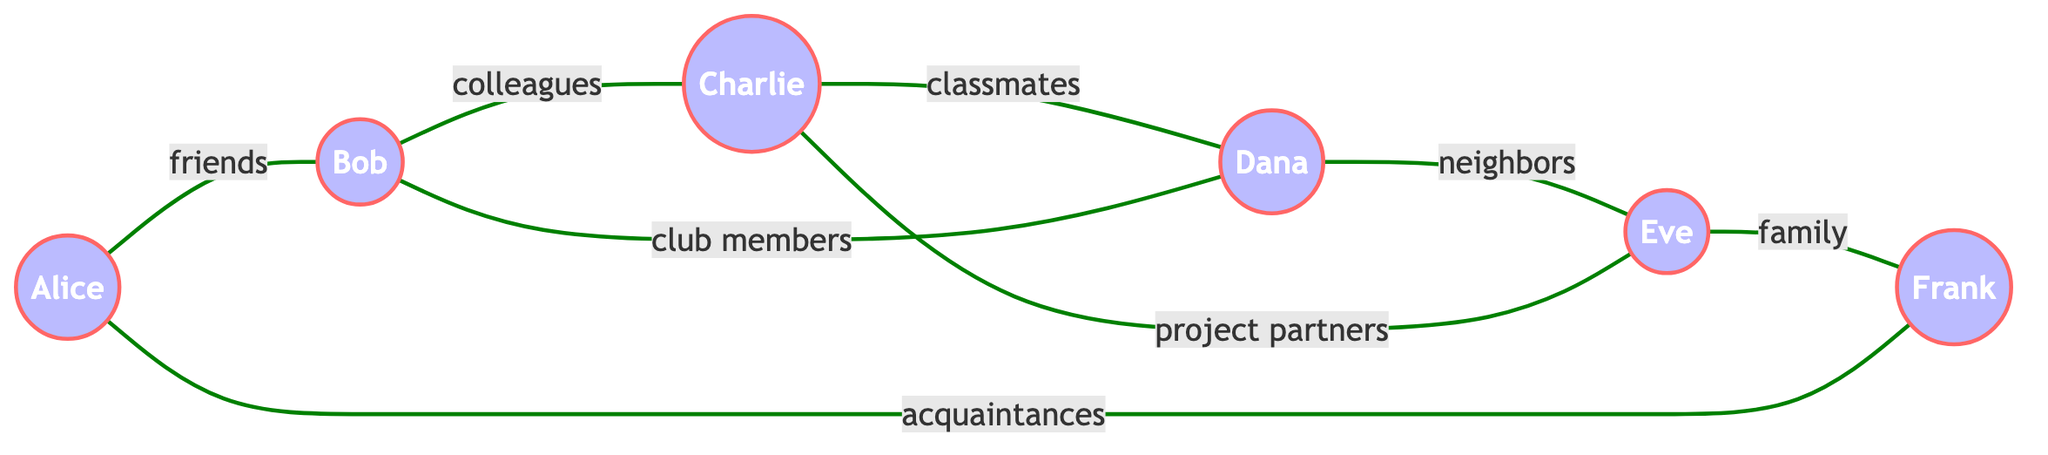What is the total number of nodes in the graph? The nodes in the graph are Alice, Bob, Charlie, Dana, Eve, and Frank. Counting these, there are six nodes in total.
Answer: 6 Which node is connected to both Bob and Dana? Observing the edges, Bob (Node 2) connects to Charlie (Node 3) and Dana (Node 4). Since Dana is directly connected to Bob's direct connection (Charlie), we recognize that there are shared connections through different nodes. The direct connection can be seen from Node 2 to Node 4.
Answer: Dana What relationship connects Alice and Frank? Checking the edge between Alice (Node 1) and Frank (Node 6), the relationship is defined as "acquaintances." Thus, we identify the relationship between these two nodes.
Answer: acquaintances How many relationships are there between Bob and Charlie? Looking at the diagram, Bob (Node 2) has a direct relationship with Charlie (Node 3) through the "colleagues" connection. The direct connect confirms a single relationship appears between them.
Answer: 1 Which entity is connected to the most other entities? Examining the nodes, Alice (Node 1), Bob (Node 2), and Charlie (Node 3) all have multiple connections. However, Bob has the most connections, specifically four (to Alice, Charlie, Dana, and Eve).
Answer: Bob Are there any nodes that form a cycle? A cycle in a graph means there is a closed path. By examining the connections, we can see that Alice → Bob → Charlie → Dana → Eve → Frank → Alice creates a closed loop, hence, confirming that nodes form a cycle.
Answer: Yes What is the relationship between Charlie and Dana? Checking the connection between Charlie (Node 3) and Dana (Node 4), we see they share the relationship defined as "classmates." This relationship phrase confirms the connection type.
Answer: classmates Which node is only a neighbor to another node? Analyzing the connections, Frank (Node 6) is directly linked only to Eve (Node 5) as "family" and does not branch out or have any other connections, meaning he is strictly a neighbor to one other node.
Answer: Frank What type of algorithm could be used to discover communities in this graph? Considering the structure of the graph and its relationships, a common community detection algorithm that could be applied includes the Louvain method, which groups nodes into communities based on their connectivity patterns.
Answer: Louvain method 